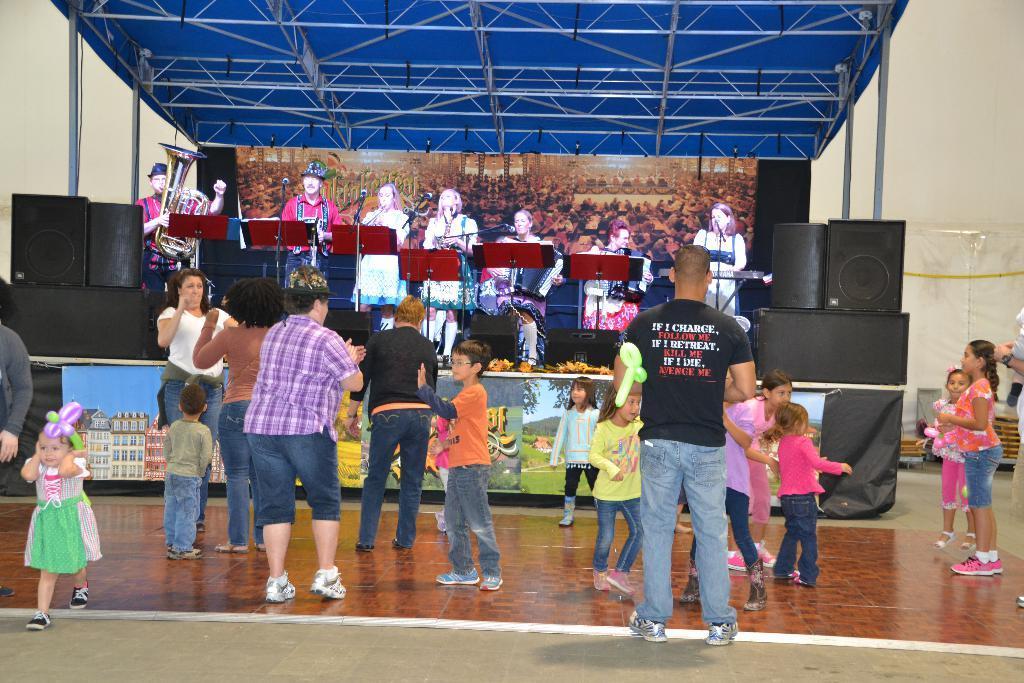In one or two sentences, can you explain what this image depicts? In this image I can see the brown colored floor and number of persons are standing on it. I can see number of persons, the stage, few persons on the stage, few microphones, few speakers, few banners, few metal rods and the cream colored wall. 